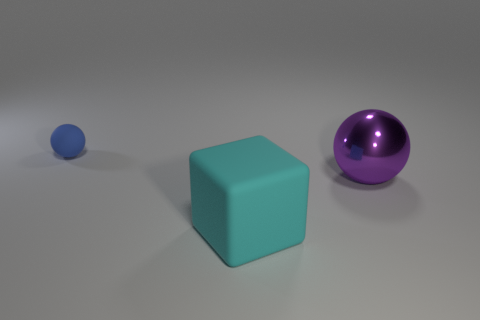Subtract all purple balls. How many balls are left? 1 Add 3 large rubber things. How many objects exist? 6 Subtract 1 balls. How many balls are left? 1 Subtract all balls. How many objects are left? 1 Subtract 1 purple balls. How many objects are left? 2 Subtract all brown spheres. Subtract all red blocks. How many spheres are left? 2 Subtract all large yellow matte balls. Subtract all balls. How many objects are left? 1 Add 2 blue rubber objects. How many blue rubber objects are left? 3 Add 2 cyan objects. How many cyan objects exist? 3 